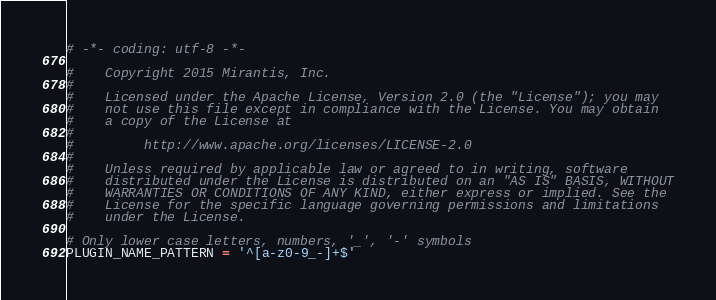<code> <loc_0><loc_0><loc_500><loc_500><_Python_># -*- coding: utf-8 -*-

#    Copyright 2015 Mirantis, Inc.
#
#    Licensed under the Apache License, Version 2.0 (the "License"); you may
#    not use this file except in compliance with the License. You may obtain
#    a copy of the License at
#
#         http://www.apache.org/licenses/LICENSE-2.0
#
#    Unless required by applicable law or agreed to in writing, software
#    distributed under the License is distributed on an "AS IS" BASIS, WITHOUT
#    WARRANTIES OR CONDITIONS OF ANY KIND, either express or implied. See the
#    License for the specific language governing permissions and limitations
#    under the License.

# Only lower case letters, numbers, '_', '-' symbols
PLUGIN_NAME_PATTERN = '^[a-z0-9_-]+$'
</code> 